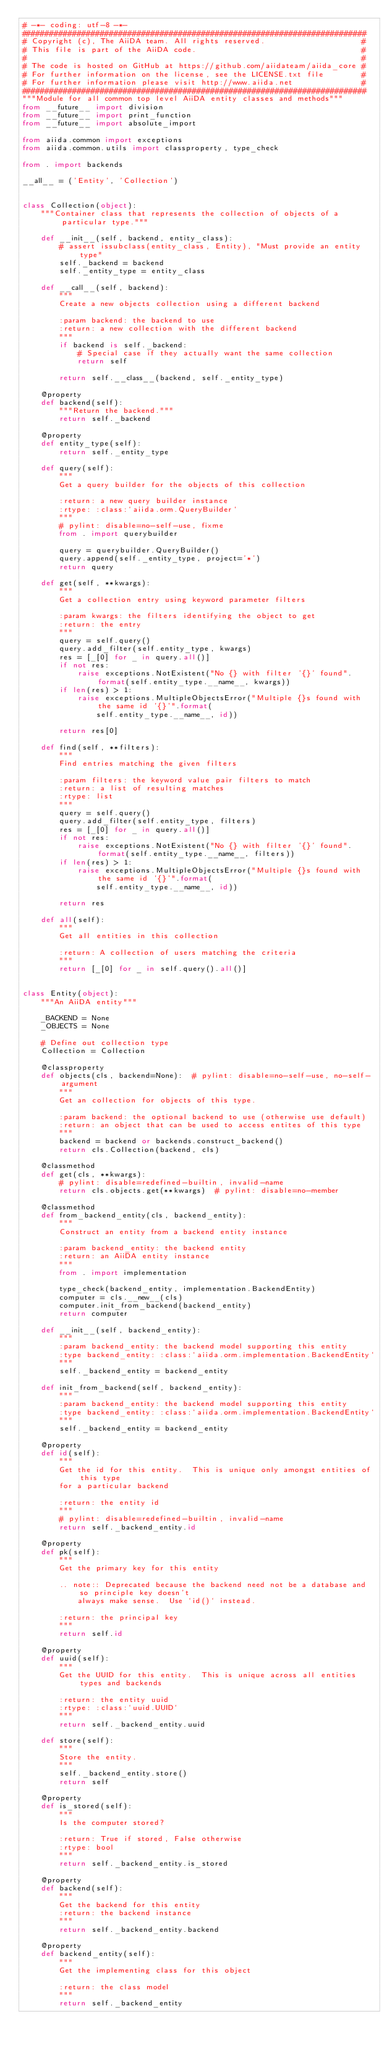Convert code to text. <code><loc_0><loc_0><loc_500><loc_500><_Python_># -*- coding: utf-8 -*-
###########################################################################
# Copyright (c), The AiiDA team. All rights reserved.                     #
# This file is part of the AiiDA code.                                    #
#                                                                         #
# The code is hosted on GitHub at https://github.com/aiidateam/aiida_core #
# For further information on the license, see the LICENSE.txt file        #
# For further information please visit http://www.aiida.net               #
###########################################################################
"""Module for all common top level AiiDA entity classes and methods"""
from __future__ import division
from __future__ import print_function
from __future__ import absolute_import

from aiida.common import exceptions
from aiida.common.utils import classproperty, type_check

from . import backends

__all__ = ('Entity', 'Collection')


class Collection(object):
    """Container class that represents the collection of objects of a particular type."""

    def __init__(self, backend, entity_class):
        # assert issubclass(entity_class, Entity), "Must provide an entity type"
        self._backend = backend
        self._entity_type = entity_class

    def __call__(self, backend):
        """
        Create a new objects collection using a different backend

        :param backend: the backend to use
        :return: a new collection with the different backend
        """
        if backend is self._backend:
            # Special case if they actually want the same collection
            return self

        return self.__class__(backend, self._entity_type)

    @property
    def backend(self):
        """Return the backend."""
        return self._backend

    @property
    def entity_type(self):
        return self._entity_type

    def query(self):
        """
        Get a query builder for the objects of this collection

        :return: a new query builder instance
        :rtype: :class:`aiida.orm.QueryBuilder`
        """
        # pylint: disable=no-self-use, fixme
        from . import querybuilder

        query = querybuilder.QueryBuilder()
        query.append(self._entity_type, project='*')
        return query

    def get(self, **kwargs):
        """
        Get a collection entry using keyword parameter filters

        :param kwargs: the filters identifying the object to get
        :return: the entry
        """
        query = self.query()
        query.add_filter(self.entity_type, kwargs)
        res = [_[0] for _ in query.all()]
        if not res:
            raise exceptions.NotExistent("No {} with filter '{}' found".format(self.entity_type.__name__, kwargs))
        if len(res) > 1:
            raise exceptions.MultipleObjectsError("Multiple {}s found with the same id '{}'".format(
                self.entity_type.__name__, id))

        return res[0]

    def find(self, **filters):
        """
        Find entries matching the given filters

        :param filters: the keyword value pair filters to match
        :return: a list of resulting matches
        :rtype: list
        """
        query = self.query()
        query.add_filter(self.entity_type, filters)
        res = [_[0] for _ in query.all()]
        if not res:
            raise exceptions.NotExistent("No {} with filter '{}' found".format(self.entity_type.__name__, filters))
        if len(res) > 1:
            raise exceptions.MultipleObjectsError("Multiple {}s found with the same id '{}'".format(
                self.entity_type.__name__, id))

        return res

    def all(self):
        """
        Get all entities in this collection

        :return: A collection of users matching the criteria
        """
        return [_[0] for _ in self.query().all()]


class Entity(object):
    """An AiiDA entity"""

    _BACKEND = None
    _OBJECTS = None

    # Define out collection type
    Collection = Collection

    @classproperty
    def objects(cls, backend=None):  # pylint: disable=no-self-use, no-self-argument
        """
        Get an collection for objects of this type.

        :param backend: the optional backend to use (otherwise use default)
        :return: an object that can be used to access entites of this type
        """
        backend = backend or backends.construct_backend()
        return cls.Collection(backend, cls)

    @classmethod
    def get(cls, **kwargs):
        # pylint: disable=redefined-builtin, invalid-name
        return cls.objects.get(**kwargs)  # pylint: disable=no-member

    @classmethod
    def from_backend_entity(cls, backend_entity):
        """
        Construct an entity from a backend entity instance

        :param backend_entity: the backend entity
        :return: an AiiDA entity instance
        """
        from . import implementation

        type_check(backend_entity, implementation.BackendEntity)
        computer = cls.__new__(cls)
        computer.init_from_backend(backend_entity)
        return computer

    def __init__(self, backend_entity):
        """
        :param backend_entity: the backend model supporting this entity
        :type backend_entity: :class:`aiida.orm.implementation.BackendEntity`
        """
        self._backend_entity = backend_entity

    def init_from_backend(self, backend_entity):
        """
        :param backend_entity: the backend model supporting this entity
        :type backend_entity: :class:`aiida.orm.implementation.BackendEntity`
        """
        self._backend_entity = backend_entity

    @property
    def id(self):
        """
        Get the id for this entity.  This is unique only amongst entities of this type
        for a particular backend

        :return: the entity id
        """
        # pylint: disable=redefined-builtin, invalid-name
        return self._backend_entity.id

    @property
    def pk(self):
        """
        Get the primary key for this entity

        .. note:: Deprecated because the backend need not be a database and so principle key doesn't
            always make sense.  Use `id()` instead.

        :return: the principal key
        """
        return self.id

    @property
    def uuid(self):
        """
        Get the UUID for this entity.  This is unique across all entities types and backends

        :return: the entity uuid
        :rtype: :class:`uuid.UUID`
        """
        return self._backend_entity.uuid

    def store(self):
        """
        Store the entity.
        """
        self._backend_entity.store()
        return self

    @property
    def is_stored(self):
        """
        Is the computer stored?

        :return: True if stored, False otherwise
        :rtype: bool
        """
        return self._backend_entity.is_stored

    @property
    def backend(self):
        """
        Get the backend for this entity
        :return: the backend instance
        """
        return self._backend_entity.backend

    @property
    def backend_entity(self):
        """
        Get the implementing class for this object

        :return: the class model
        """
        return self._backend_entity
</code> 